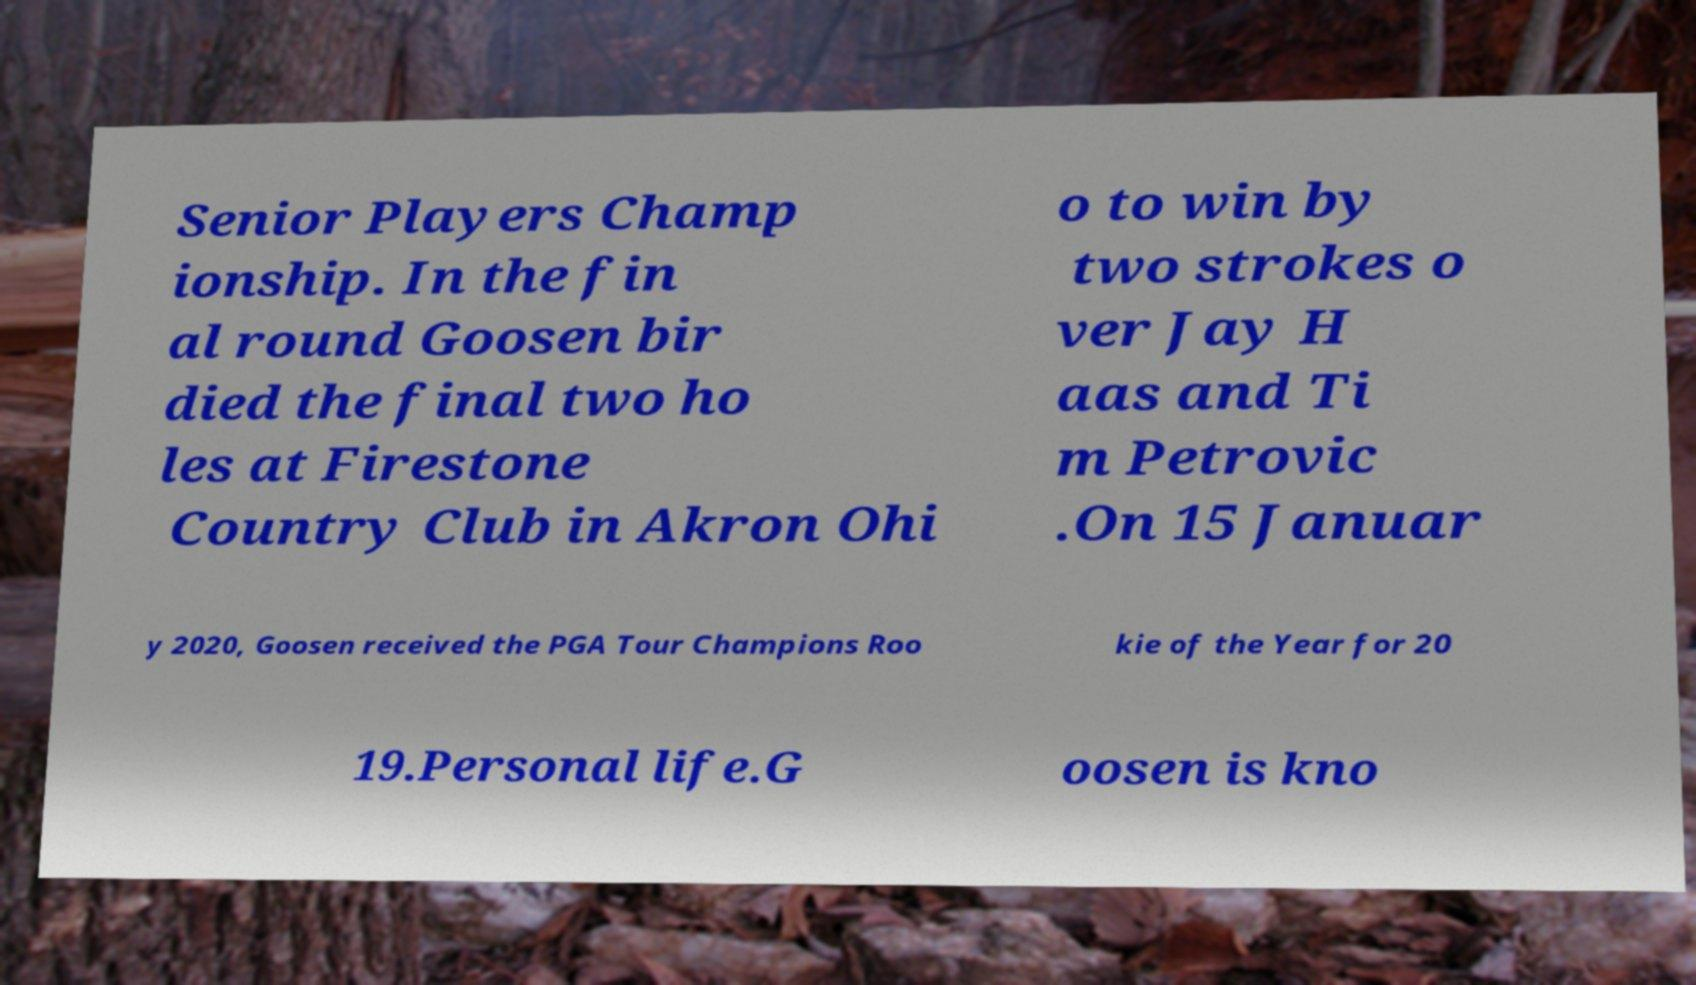Please read and relay the text visible in this image. What does it say? Senior Players Champ ionship. In the fin al round Goosen bir died the final two ho les at Firestone Country Club in Akron Ohi o to win by two strokes o ver Jay H aas and Ti m Petrovic .On 15 Januar y 2020, Goosen received the PGA Tour Champions Roo kie of the Year for 20 19.Personal life.G oosen is kno 